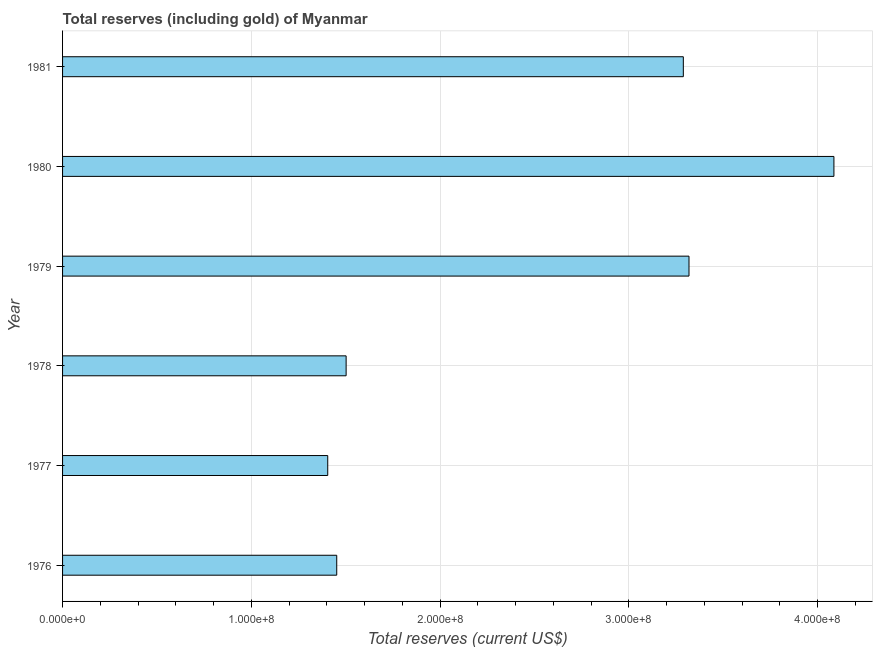Does the graph contain grids?
Provide a short and direct response. Yes. What is the title of the graph?
Keep it short and to the point. Total reserves (including gold) of Myanmar. What is the label or title of the X-axis?
Give a very brief answer. Total reserves (current US$). What is the label or title of the Y-axis?
Offer a terse response. Year. What is the total reserves (including gold) in 1981?
Provide a succinct answer. 3.29e+08. Across all years, what is the maximum total reserves (including gold)?
Keep it short and to the point. 4.09e+08. Across all years, what is the minimum total reserves (including gold)?
Make the answer very short. 1.40e+08. What is the sum of the total reserves (including gold)?
Your response must be concise. 1.51e+09. What is the difference between the total reserves (including gold) in 1979 and 1980?
Provide a succinct answer. -7.68e+07. What is the average total reserves (including gold) per year?
Offer a very short reply. 2.51e+08. What is the median total reserves (including gold)?
Your answer should be compact. 2.40e+08. In how many years, is the total reserves (including gold) greater than 380000000 US$?
Give a very brief answer. 1. What is the ratio of the total reserves (including gold) in 1976 to that in 1980?
Your response must be concise. 0.35. Is the total reserves (including gold) in 1978 less than that in 1980?
Ensure brevity in your answer.  Yes. Is the difference between the total reserves (including gold) in 1978 and 1981 greater than the difference between any two years?
Provide a succinct answer. No. What is the difference between the highest and the second highest total reserves (including gold)?
Provide a short and direct response. 7.68e+07. What is the difference between the highest and the lowest total reserves (including gold)?
Provide a short and direct response. 2.68e+08. In how many years, is the total reserves (including gold) greater than the average total reserves (including gold) taken over all years?
Your answer should be very brief. 3. Are all the bars in the graph horizontal?
Your answer should be compact. Yes. What is the difference between two consecutive major ticks on the X-axis?
Your response must be concise. 1.00e+08. Are the values on the major ticks of X-axis written in scientific E-notation?
Provide a succinct answer. Yes. What is the Total reserves (current US$) in 1976?
Make the answer very short. 1.45e+08. What is the Total reserves (current US$) of 1977?
Offer a very short reply. 1.40e+08. What is the Total reserves (current US$) in 1978?
Ensure brevity in your answer.  1.50e+08. What is the Total reserves (current US$) in 1979?
Your answer should be very brief. 3.32e+08. What is the Total reserves (current US$) of 1980?
Your answer should be compact. 4.09e+08. What is the Total reserves (current US$) of 1981?
Offer a very short reply. 3.29e+08. What is the difference between the Total reserves (current US$) in 1976 and 1977?
Offer a very short reply. 4.77e+06. What is the difference between the Total reserves (current US$) in 1976 and 1978?
Offer a very short reply. -4.98e+06. What is the difference between the Total reserves (current US$) in 1976 and 1979?
Your answer should be very brief. -1.87e+08. What is the difference between the Total reserves (current US$) in 1976 and 1980?
Provide a short and direct response. -2.63e+08. What is the difference between the Total reserves (current US$) in 1976 and 1981?
Ensure brevity in your answer.  -1.84e+08. What is the difference between the Total reserves (current US$) in 1977 and 1978?
Provide a succinct answer. -9.75e+06. What is the difference between the Total reserves (current US$) in 1977 and 1979?
Give a very brief answer. -1.91e+08. What is the difference between the Total reserves (current US$) in 1977 and 1980?
Offer a terse response. -2.68e+08. What is the difference between the Total reserves (current US$) in 1977 and 1981?
Keep it short and to the point. -1.88e+08. What is the difference between the Total reserves (current US$) in 1978 and 1979?
Keep it short and to the point. -1.82e+08. What is the difference between the Total reserves (current US$) in 1978 and 1980?
Your answer should be very brief. -2.58e+08. What is the difference between the Total reserves (current US$) in 1978 and 1981?
Provide a succinct answer. -1.79e+08. What is the difference between the Total reserves (current US$) in 1979 and 1980?
Make the answer very short. -7.68e+07. What is the difference between the Total reserves (current US$) in 1979 and 1981?
Ensure brevity in your answer.  3.00e+06. What is the difference between the Total reserves (current US$) in 1980 and 1981?
Keep it short and to the point. 7.98e+07. What is the ratio of the Total reserves (current US$) in 1976 to that in 1977?
Give a very brief answer. 1.03. What is the ratio of the Total reserves (current US$) in 1976 to that in 1979?
Offer a very short reply. 0.44. What is the ratio of the Total reserves (current US$) in 1976 to that in 1980?
Your answer should be very brief. 0.35. What is the ratio of the Total reserves (current US$) in 1976 to that in 1981?
Make the answer very short. 0.44. What is the ratio of the Total reserves (current US$) in 1977 to that in 1978?
Your answer should be compact. 0.94. What is the ratio of the Total reserves (current US$) in 1977 to that in 1979?
Keep it short and to the point. 0.42. What is the ratio of the Total reserves (current US$) in 1977 to that in 1980?
Provide a short and direct response. 0.34. What is the ratio of the Total reserves (current US$) in 1977 to that in 1981?
Give a very brief answer. 0.43. What is the ratio of the Total reserves (current US$) in 1978 to that in 1979?
Offer a terse response. 0.45. What is the ratio of the Total reserves (current US$) in 1978 to that in 1980?
Provide a succinct answer. 0.37. What is the ratio of the Total reserves (current US$) in 1978 to that in 1981?
Provide a short and direct response. 0.46. What is the ratio of the Total reserves (current US$) in 1979 to that in 1980?
Make the answer very short. 0.81. What is the ratio of the Total reserves (current US$) in 1979 to that in 1981?
Provide a succinct answer. 1.01. What is the ratio of the Total reserves (current US$) in 1980 to that in 1981?
Your answer should be compact. 1.24. 